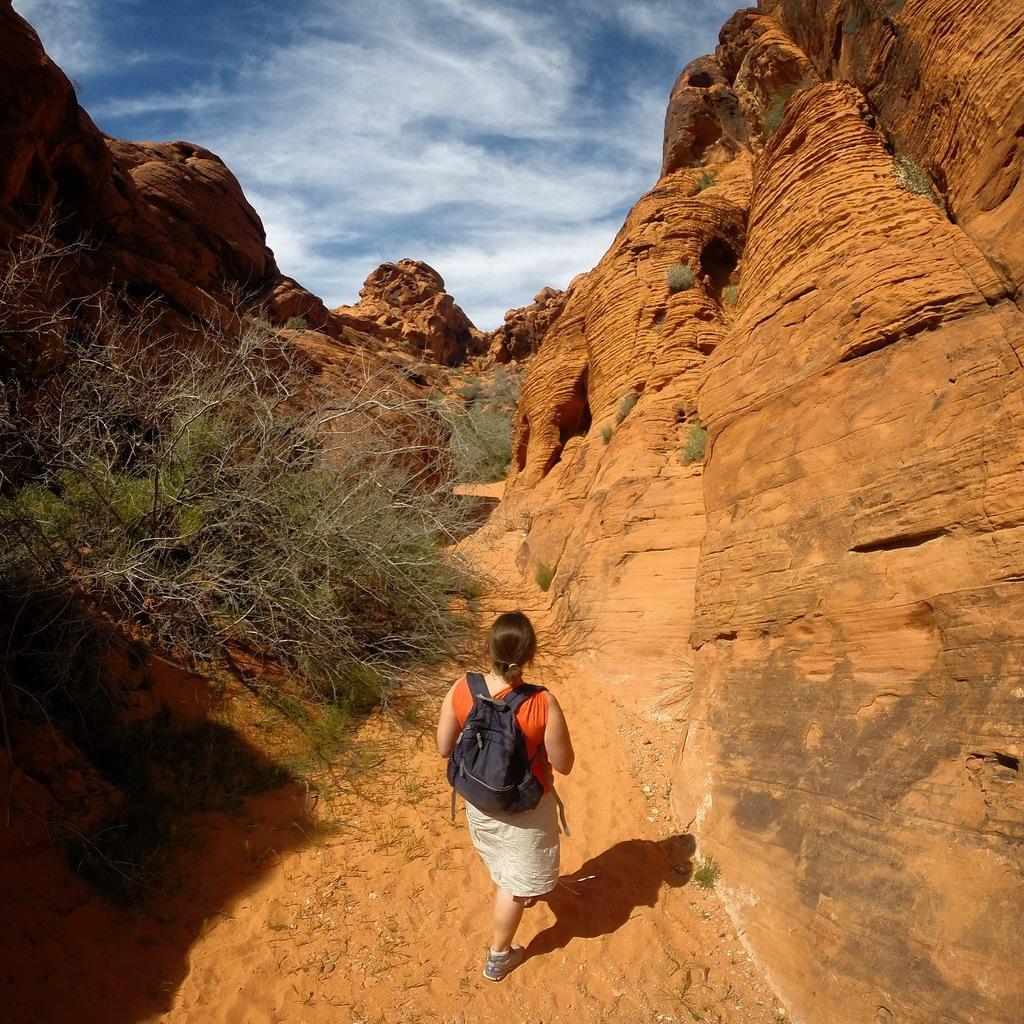How would you summarize this image in a sentence or two? In between two rocks there is a woman in the image who is wearing orange color top and cream color bottom. She is wearing her bag and walking on sand. On top we can see a sky cloudy. 